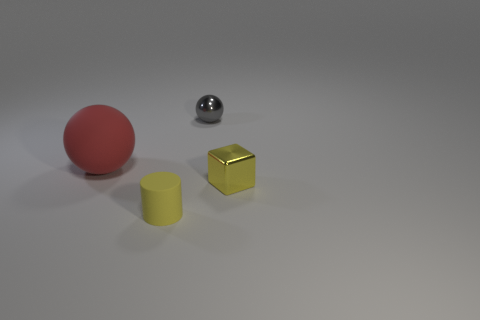Is there anything else that has the same size as the yellow cylinder?
Provide a succinct answer. Yes. What color is the cube that is the same material as the tiny gray thing?
Offer a terse response. Yellow. There is a thing that is left of the small gray shiny thing and to the right of the red sphere; what is its size?
Provide a short and direct response. Small. Is the number of small yellow matte objects that are behind the yellow block less than the number of yellow matte objects in front of the matte cylinder?
Your answer should be compact. No. Is the material of the tiny thing that is left of the tiny sphere the same as the sphere that is behind the red matte thing?
Your answer should be very brief. No. There is a cylinder that is the same color as the tiny cube; what is it made of?
Give a very brief answer. Rubber. What shape is the small thing that is both in front of the tiny gray sphere and right of the tiny cylinder?
Provide a succinct answer. Cube. What is the small thing that is behind the metal thing that is in front of the red sphere made of?
Your answer should be compact. Metal. Is the number of tiny balls greater than the number of tiny objects?
Offer a terse response. No. Is the cylinder the same color as the tiny shiny cube?
Your response must be concise. Yes. 